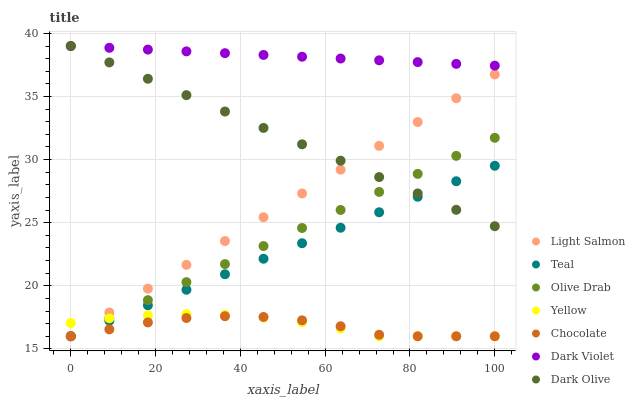Does Chocolate have the minimum area under the curve?
Answer yes or no. Yes. Does Dark Violet have the maximum area under the curve?
Answer yes or no. Yes. Does Dark Olive have the minimum area under the curve?
Answer yes or no. No. Does Dark Olive have the maximum area under the curve?
Answer yes or no. No. Is Teal the smoothest?
Answer yes or no. Yes. Is Chocolate the roughest?
Answer yes or no. Yes. Is Dark Olive the smoothest?
Answer yes or no. No. Is Dark Olive the roughest?
Answer yes or no. No. Does Light Salmon have the lowest value?
Answer yes or no. Yes. Does Dark Olive have the lowest value?
Answer yes or no. No. Does Dark Violet have the highest value?
Answer yes or no. Yes. Does Chocolate have the highest value?
Answer yes or no. No. Is Yellow less than Dark Olive?
Answer yes or no. Yes. Is Dark Olive greater than Yellow?
Answer yes or no. Yes. Does Olive Drab intersect Chocolate?
Answer yes or no. Yes. Is Olive Drab less than Chocolate?
Answer yes or no. No. Is Olive Drab greater than Chocolate?
Answer yes or no. No. Does Yellow intersect Dark Olive?
Answer yes or no. No. 